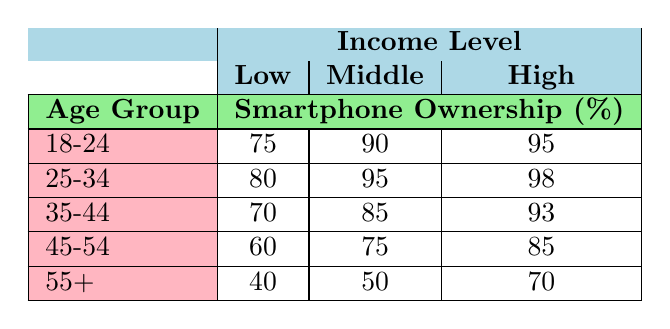What is the smartphone ownership percentage for the 45-54 age group and high income level? According to the table, under the age group 45-54 and income level high, the smartphone ownership percentage is indicated as 85%.
Answer: 85 What is the lowest smartphone ownership percentage across all age groups? The table reveals that the lowest smartphone ownership percentage occurs in the age group 55+ with the low income level, which is 40%.
Answer: 40 Which age group has the highest smartphone ownership percentage for the middle-income level? By reviewing the data, the age group 25-34 displays the highest smartphone ownership percentage at the middle-income level, registered at 95%.
Answer: 95 Is smartphone ownership higher among those aged 18-24 compared to those aged 55+ at the low-income level? Upon comparing the data, the age group 18-24 has a smartphone ownership of 75% at the low-income level, while the 55+ age group has 40%. Thus, ownership is indeed higher for 18-24.
Answer: Yes What is the average smartphone ownership percentage for the 25-34 age group? To calculate the average for the age group 25-34, we take the percentages: 80 (low) + 95 (middle) + 98 (high) = 273, then divide by the number of income levels, which is 3: 273/3 = 91.
Answer: 91 For the high-income level, which age group has the greatest smartphone ownership increase compared to the low-income level? Analyzing the values, the age group 18-24 shows an increase from 75% (low) to 95% (high), a difference of 20%. The age group 25-34 shows an increase from 80% (low) to 98% (high), a difference of 18%. The age group 35-44 moves from 70% to 93%, a difference of 23%. The age group 45-54 has an increase from 60% to 85%, which is 25%, and finally, the 55+ age group goes from 40% to 70%, a difference of 30%. The greatest increase is for the 55+ age group.
Answer: 55+ Is it true that all age groups have higher smartphone ownership percentages in the high-income level compared to the low-income level? We compare each age group: 18-24 (95% high vs 75% low), 25-34 (98% high vs 80% low), 35-44 (93% high vs 70% low), 45-54 (85% high vs 60% low), and 55+ (70% high vs 40% low). All comparisons show a higher percentage in the high-income level, so the statement is true.
Answer: Yes 